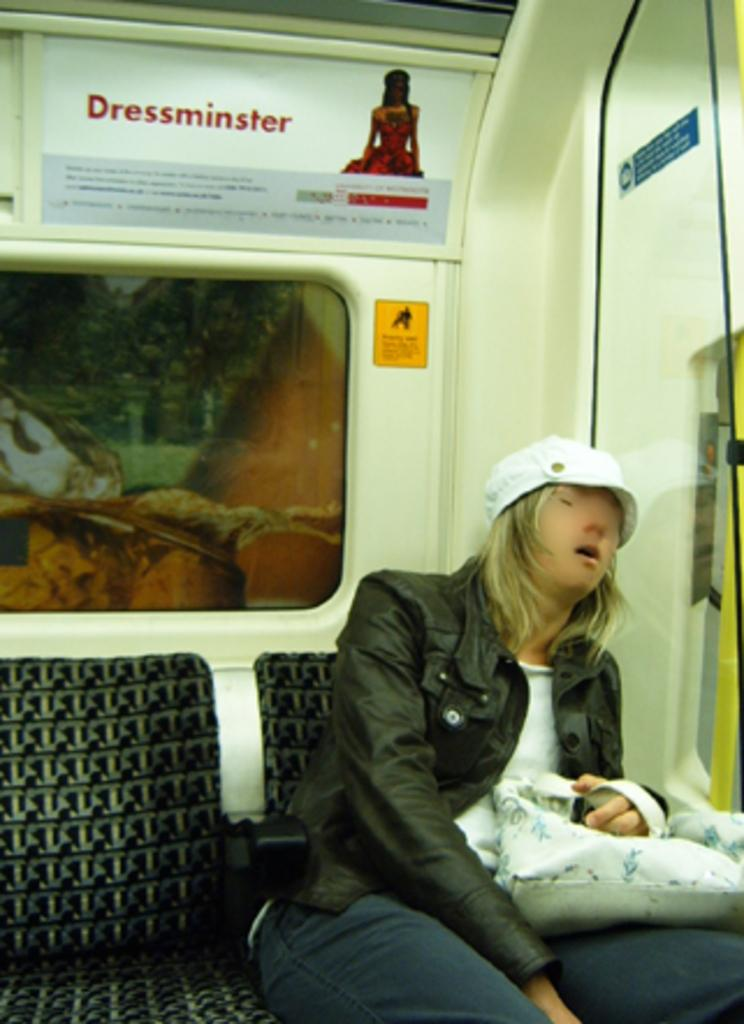What is the main subject of the image? The main subject of the image is a vehicle. What distinguishes this vehicle from others? The vehicle has a banner. Who is inside the vehicle? There is a woman in the vehicle. What is the woman wearing? The woman is wearing a black jacket and a white hat. What is the woman holding? The woman is holding a handbag. What type of bed is visible in the image? There is no bed present in the image; it features a vehicle with a woman inside. 